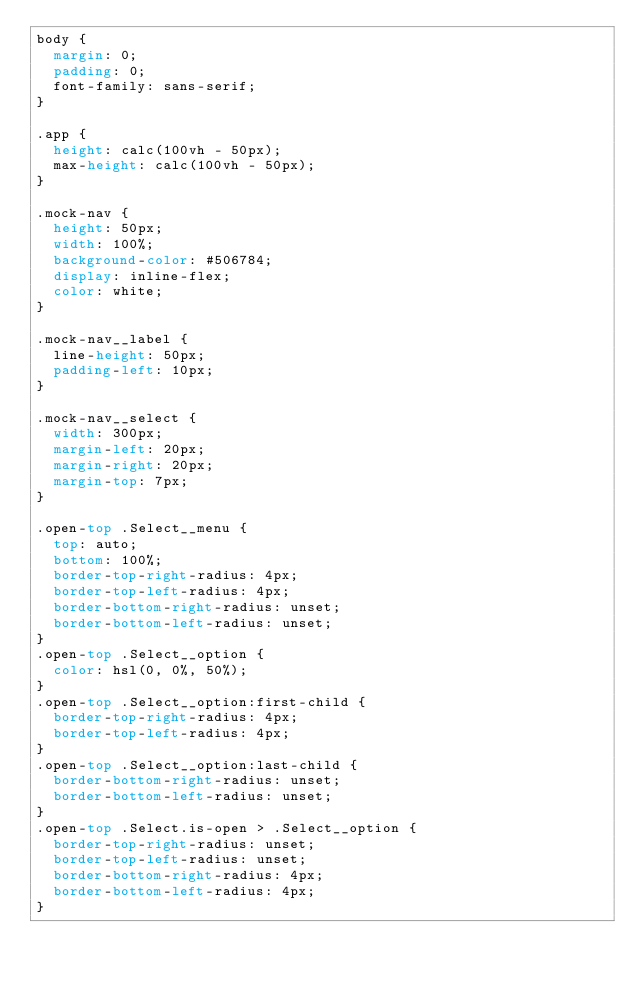<code> <loc_0><loc_0><loc_500><loc_500><_CSS_>body {
  margin: 0;
  padding: 0;
  font-family: sans-serif;
}

.app {
  height: calc(100vh - 50px);
  max-height: calc(100vh - 50px);
}

.mock-nav {
  height: 50px;
  width: 100%;
  background-color: #506784;
  display: inline-flex;
  color: white;
}

.mock-nav__label {
  line-height: 50px;
  padding-left: 10px;
}

.mock-nav__select {
  width: 300px;
  margin-left: 20px;
  margin-right: 20px;
  margin-top: 7px;
}

.open-top .Select__menu {
  top: auto;
  bottom: 100%;
  border-top-right-radius: 4px;
  border-top-left-radius: 4px;
  border-bottom-right-radius: unset;
  border-bottom-left-radius: unset;
}
.open-top .Select__option {
  color: hsl(0, 0%, 50%);
}
.open-top .Select__option:first-child {
  border-top-right-radius: 4px;
  border-top-left-radius: 4px;
}
.open-top .Select__option:last-child {
  border-bottom-right-radius: unset;
  border-bottom-left-radius: unset;
}
.open-top .Select.is-open > .Select__option {
  border-top-right-radius: unset;
  border-top-left-radius: unset;
  border-bottom-right-radius: 4px;
  border-bottom-left-radius: 4px;
}
</code> 